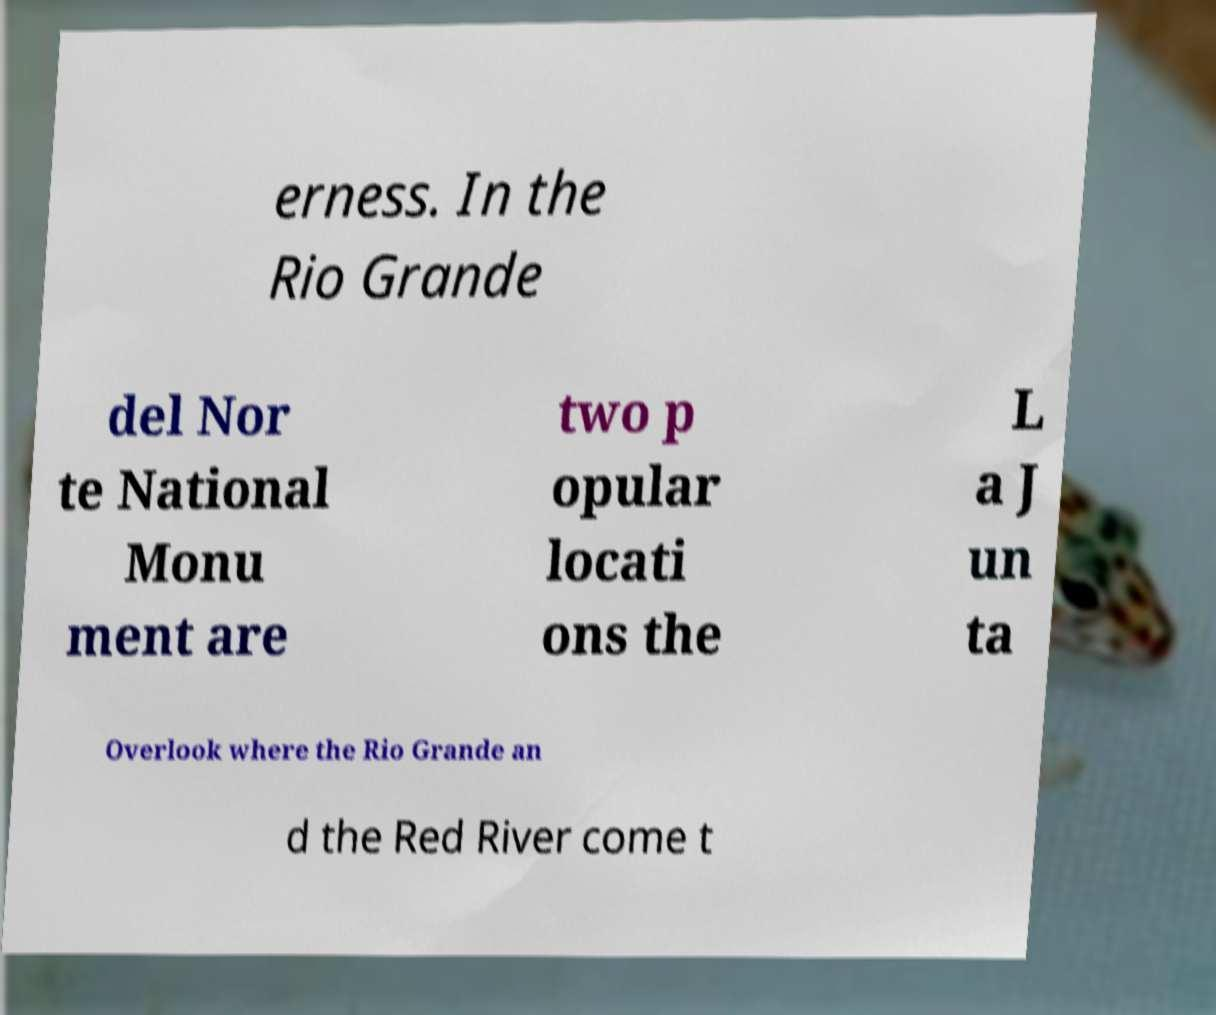There's text embedded in this image that I need extracted. Can you transcribe it verbatim? erness. In the Rio Grande del Nor te National Monu ment are two p opular locati ons the L a J un ta Overlook where the Rio Grande an d the Red River come t 